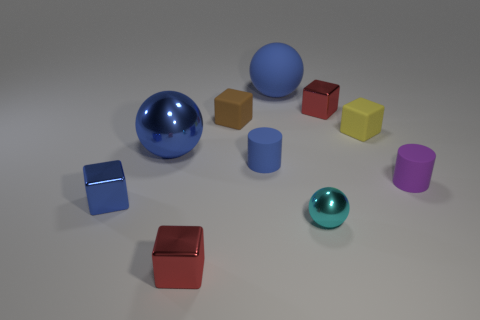Is there a shiny sphere that has the same size as the blue matte sphere?
Your answer should be compact. Yes. There is a cyan object; is its shape the same as the blue shiny thing behind the purple matte cylinder?
Make the answer very short. Yes. Does the red metallic block that is in front of the purple thing have the same size as the blue sphere that is left of the rubber sphere?
Make the answer very short. No. How many other objects are the same shape as the small blue shiny thing?
Your answer should be compact. 4. What material is the small cube on the right side of the small red shiny cube that is behind the small blue cube?
Ensure brevity in your answer.  Rubber. What number of rubber objects are purple objects or tiny objects?
Offer a terse response. 4. Is there anything else that is the same material as the tiny cyan sphere?
Make the answer very short. Yes. Are there any cyan metallic balls left of the metallic sphere that is on the right side of the large blue matte sphere?
Offer a terse response. No. How many objects are either blue metal objects in front of the small blue rubber cylinder or tiny red metal blocks in front of the blue metallic cube?
Offer a very short reply. 2. Are there any other things that are the same color as the big shiny object?
Give a very brief answer. Yes. 